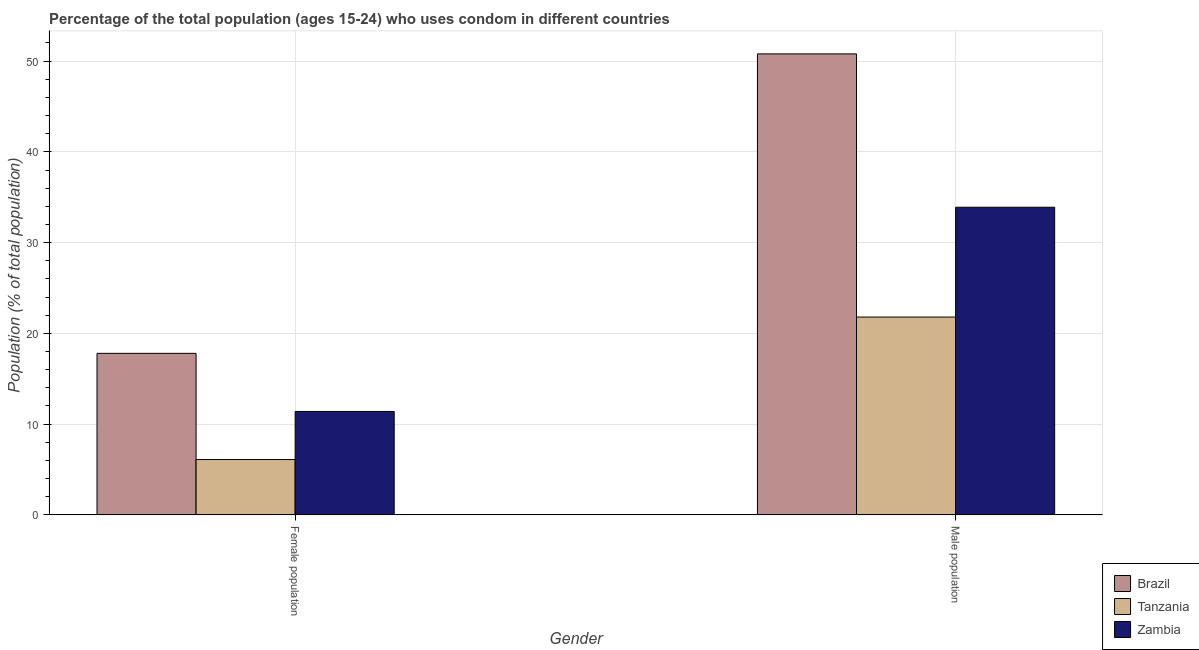How many groups of bars are there?
Your answer should be compact. 2. Are the number of bars on each tick of the X-axis equal?
Your answer should be very brief. Yes. How many bars are there on the 2nd tick from the left?
Your answer should be compact. 3. How many bars are there on the 2nd tick from the right?
Make the answer very short. 3. What is the label of the 1st group of bars from the left?
Keep it short and to the point. Female population. What is the female population in Tanzania?
Your answer should be very brief. 6.1. Across all countries, what is the minimum male population?
Offer a terse response. 21.8. In which country was the male population maximum?
Offer a very short reply. Brazil. In which country was the male population minimum?
Keep it short and to the point. Tanzania. What is the total female population in the graph?
Offer a terse response. 35.3. What is the difference between the female population in Tanzania and that in Zambia?
Provide a short and direct response. -5.3. What is the difference between the female population in Brazil and the male population in Tanzania?
Provide a short and direct response. -4. What is the average female population per country?
Offer a very short reply. 11.77. What is the difference between the male population and female population in Zambia?
Offer a very short reply. 22.5. In how many countries, is the male population greater than 28 %?
Ensure brevity in your answer.  2. What is the ratio of the male population in Brazil to that in Zambia?
Make the answer very short. 1.5. In how many countries, is the male population greater than the average male population taken over all countries?
Provide a succinct answer. 1. What does the 2nd bar from the left in Male population represents?
Your answer should be very brief. Tanzania. What does the 3rd bar from the right in Male population represents?
Your response must be concise. Brazil. What is the difference between two consecutive major ticks on the Y-axis?
Keep it short and to the point. 10. Are the values on the major ticks of Y-axis written in scientific E-notation?
Make the answer very short. No. How many legend labels are there?
Provide a short and direct response. 3. What is the title of the graph?
Your answer should be very brief. Percentage of the total population (ages 15-24) who uses condom in different countries. Does "Egypt, Arab Rep." appear as one of the legend labels in the graph?
Your response must be concise. No. What is the label or title of the X-axis?
Offer a very short reply. Gender. What is the label or title of the Y-axis?
Provide a succinct answer. Population (% of total population) . What is the Population (% of total population)  of Tanzania in Female population?
Offer a terse response. 6.1. What is the Population (% of total population)  of Brazil in Male population?
Offer a terse response. 50.8. What is the Population (% of total population)  of Tanzania in Male population?
Offer a terse response. 21.8. What is the Population (% of total population)  of Zambia in Male population?
Ensure brevity in your answer.  33.9. Across all Gender, what is the maximum Population (% of total population)  in Brazil?
Provide a succinct answer. 50.8. Across all Gender, what is the maximum Population (% of total population)  of Tanzania?
Your answer should be very brief. 21.8. Across all Gender, what is the maximum Population (% of total population)  of Zambia?
Keep it short and to the point. 33.9. Across all Gender, what is the minimum Population (% of total population)  of Tanzania?
Offer a terse response. 6.1. Across all Gender, what is the minimum Population (% of total population)  of Zambia?
Your answer should be compact. 11.4. What is the total Population (% of total population)  of Brazil in the graph?
Give a very brief answer. 68.6. What is the total Population (% of total population)  in Tanzania in the graph?
Give a very brief answer. 27.9. What is the total Population (% of total population)  in Zambia in the graph?
Give a very brief answer. 45.3. What is the difference between the Population (% of total population)  of Brazil in Female population and that in Male population?
Your answer should be very brief. -33. What is the difference between the Population (% of total population)  of Tanzania in Female population and that in Male population?
Your answer should be compact. -15.7. What is the difference between the Population (% of total population)  in Zambia in Female population and that in Male population?
Your response must be concise. -22.5. What is the difference between the Population (% of total population)  of Brazil in Female population and the Population (% of total population)  of Zambia in Male population?
Ensure brevity in your answer.  -16.1. What is the difference between the Population (% of total population)  of Tanzania in Female population and the Population (% of total population)  of Zambia in Male population?
Your response must be concise. -27.8. What is the average Population (% of total population)  of Brazil per Gender?
Give a very brief answer. 34.3. What is the average Population (% of total population)  of Tanzania per Gender?
Make the answer very short. 13.95. What is the average Population (% of total population)  in Zambia per Gender?
Keep it short and to the point. 22.65. What is the difference between the Population (% of total population)  of Brazil and Population (% of total population)  of Zambia in Female population?
Provide a short and direct response. 6.4. What is the difference between the Population (% of total population)  of Brazil and Population (% of total population)  of Tanzania in Male population?
Provide a succinct answer. 29. What is the difference between the Population (% of total population)  in Tanzania and Population (% of total population)  in Zambia in Male population?
Offer a very short reply. -12.1. What is the ratio of the Population (% of total population)  of Brazil in Female population to that in Male population?
Your response must be concise. 0.35. What is the ratio of the Population (% of total population)  in Tanzania in Female population to that in Male population?
Provide a short and direct response. 0.28. What is the ratio of the Population (% of total population)  in Zambia in Female population to that in Male population?
Your answer should be compact. 0.34. What is the difference between the highest and the second highest Population (% of total population)  of Tanzania?
Your response must be concise. 15.7. What is the difference between the highest and the lowest Population (% of total population)  in Zambia?
Provide a short and direct response. 22.5. 